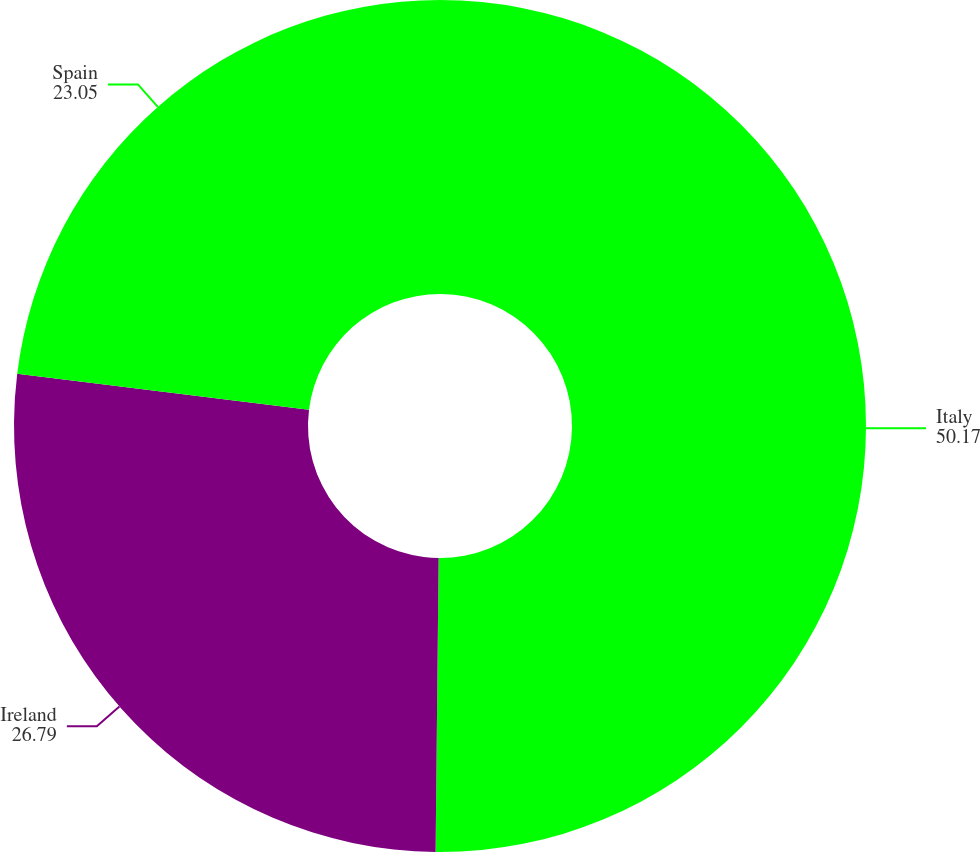Convert chart. <chart><loc_0><loc_0><loc_500><loc_500><pie_chart><fcel>Italy<fcel>Ireland<fcel>Spain<nl><fcel>50.17%<fcel>26.79%<fcel>23.05%<nl></chart> 